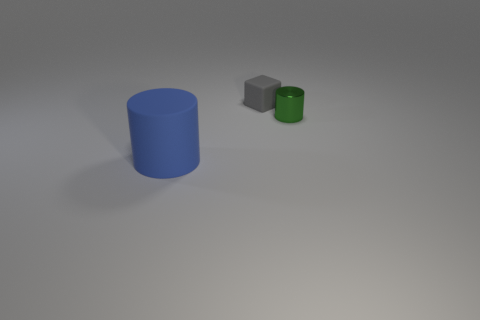Does the big cylinder have the same material as the green object?
Your response must be concise. No. What is the color of the cylinder to the left of the small metallic cylinder?
Offer a terse response. Blue. What is the material of the thing that is left of the tiny green shiny object and in front of the small matte block?
Keep it short and to the point. Rubber. There is a gray object that is made of the same material as the big cylinder; what is its shape?
Provide a short and direct response. Cube. There is a tiny thing to the left of the green shiny cylinder; what number of small things are in front of it?
Keep it short and to the point. 1. What number of things are in front of the green thing and behind the metallic cylinder?
Keep it short and to the point. 0. What number of other objects are the same material as the small green cylinder?
Your answer should be very brief. 0. What is the color of the object behind the cylinder that is right of the rubber cylinder?
Your response must be concise. Gray. Do the green object and the blue matte thing have the same size?
Your answer should be very brief. No. The rubber object that is the same size as the green cylinder is what shape?
Offer a very short reply. Cube. 